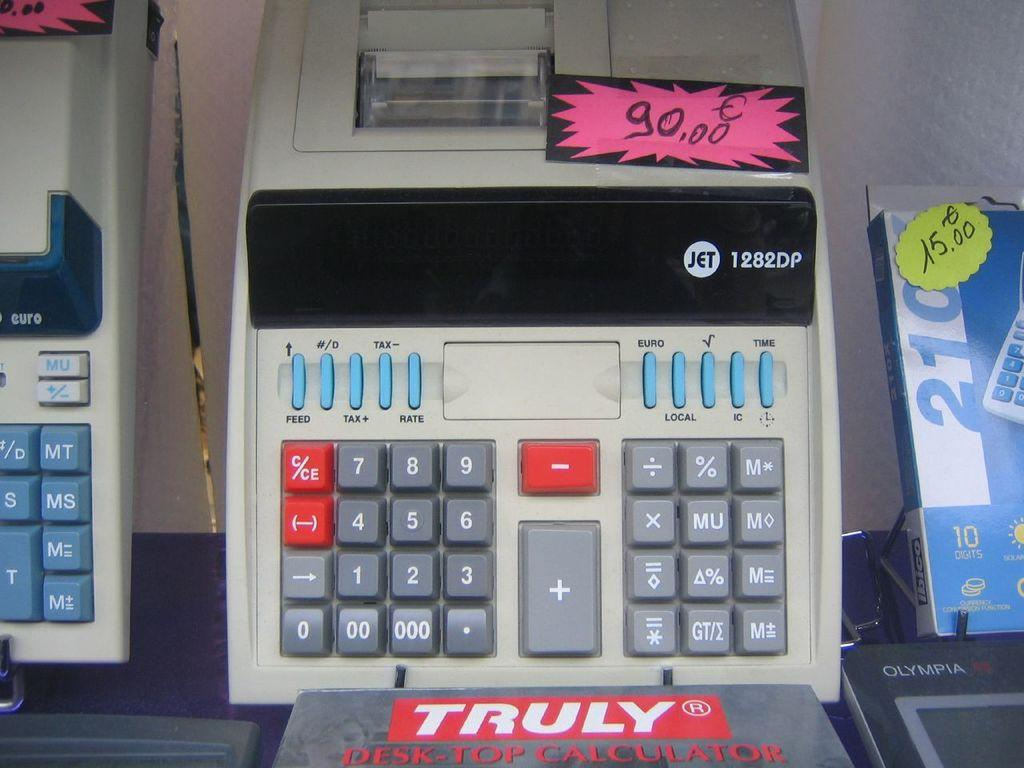<image>
Share a concise interpretation of the image provided. A calculator sits on display with the price of 90.00. 